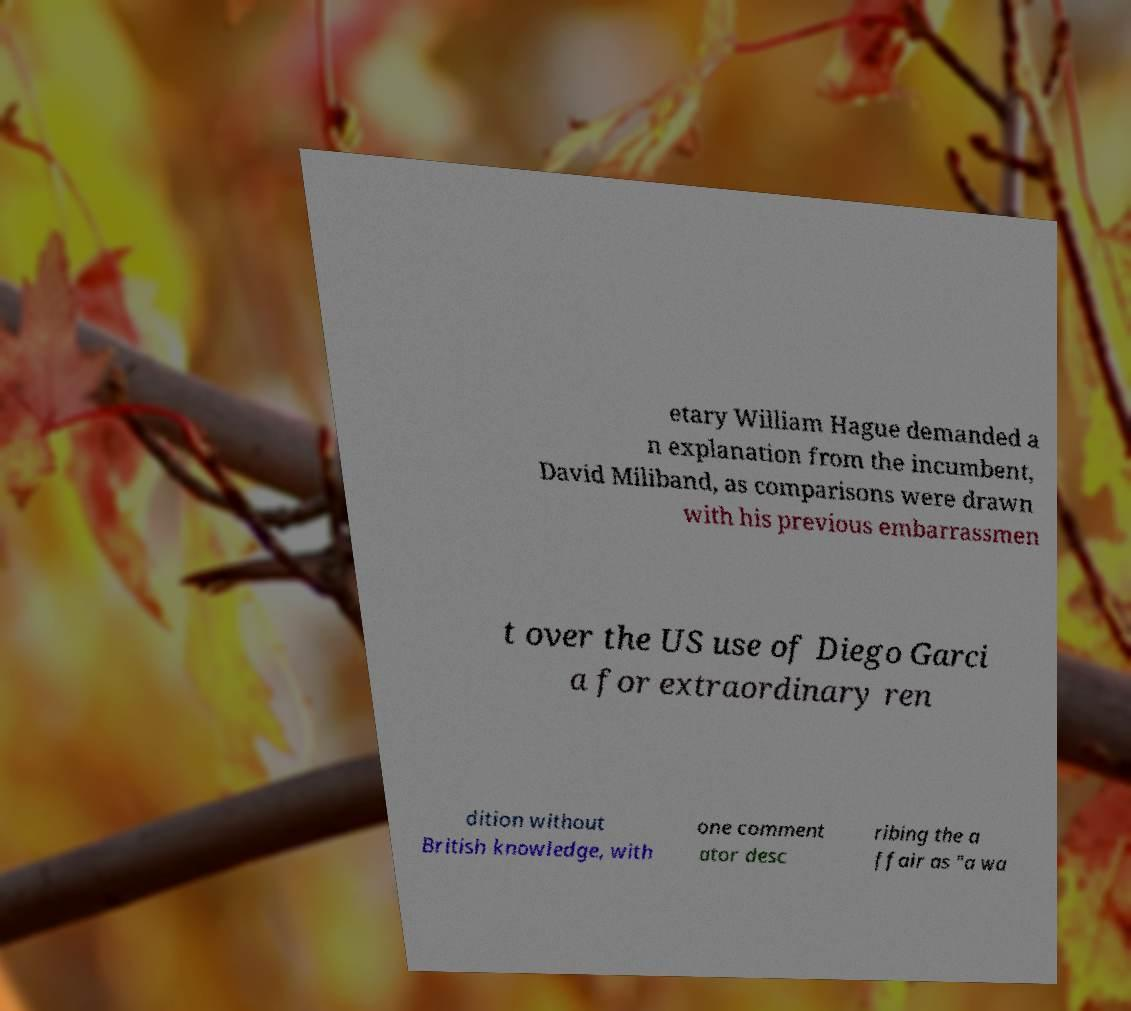Please read and relay the text visible in this image. What does it say? etary William Hague demanded a n explanation from the incumbent, David Miliband, as comparisons were drawn with his previous embarrassmen t over the US use of Diego Garci a for extraordinary ren dition without British knowledge, with one comment ator desc ribing the a ffair as "a wa 